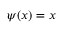Convert formula to latex. <formula><loc_0><loc_0><loc_500><loc_500>\psi ( x ) = x</formula> 